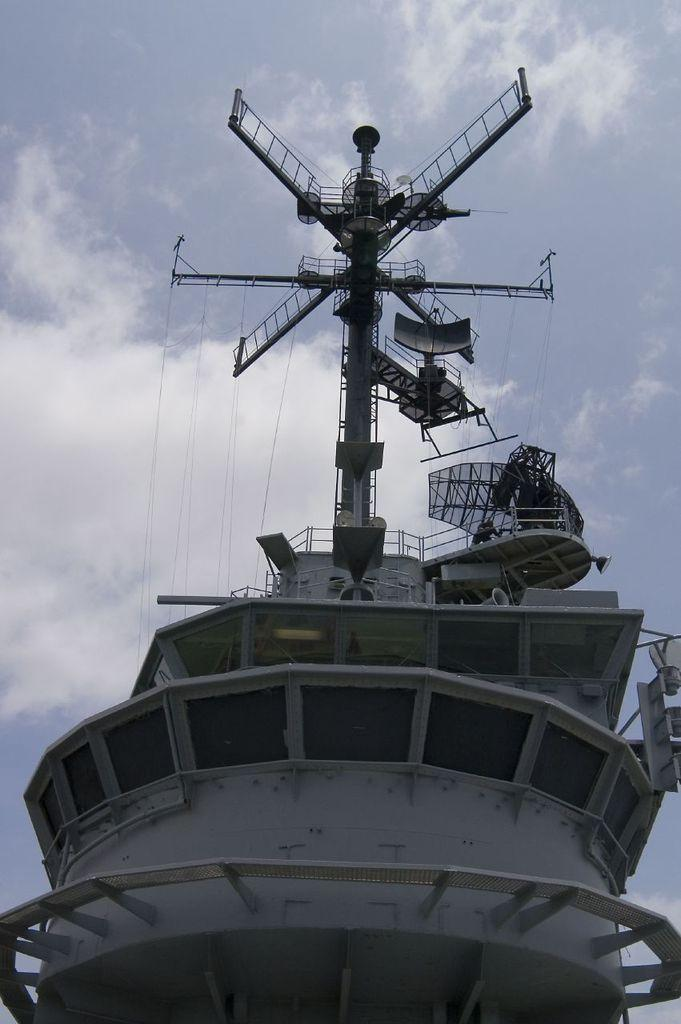What is present on the ship in the image? There is a pole on the ship in the image. What is connected to the pole? Cables are attached to the pole. What can be seen in the background behind the pole? The sky is visible behind the pole. What type of prose is written on the sign near the pole? There is no sign present in the image, so there is no prose to analyze. 